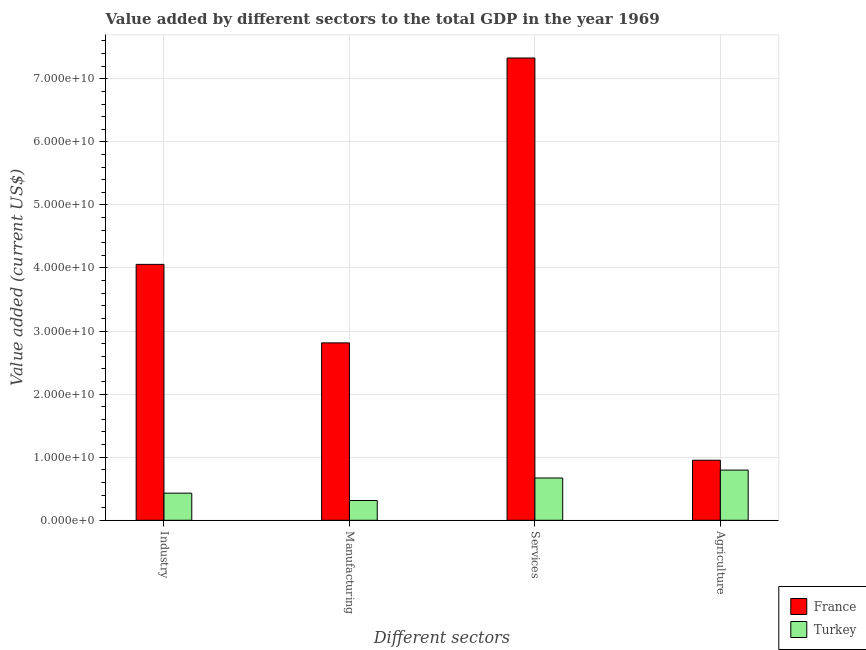How many different coloured bars are there?
Your response must be concise. 2. Are the number of bars per tick equal to the number of legend labels?
Provide a succinct answer. Yes. Are the number of bars on each tick of the X-axis equal?
Give a very brief answer. Yes. How many bars are there on the 3rd tick from the right?
Your response must be concise. 2. What is the label of the 3rd group of bars from the left?
Provide a short and direct response. Services. What is the value added by services sector in Turkey?
Your answer should be very brief. 6.70e+09. Across all countries, what is the maximum value added by services sector?
Ensure brevity in your answer.  7.33e+1. Across all countries, what is the minimum value added by manufacturing sector?
Give a very brief answer. 3.13e+09. In which country was the value added by services sector maximum?
Keep it short and to the point. France. What is the total value added by agricultural sector in the graph?
Offer a very short reply. 1.75e+1. What is the difference between the value added by agricultural sector in France and that in Turkey?
Offer a very short reply. 1.57e+09. What is the difference between the value added by manufacturing sector in Turkey and the value added by services sector in France?
Keep it short and to the point. -7.02e+1. What is the average value added by services sector per country?
Your answer should be compact. 4.00e+1. What is the difference between the value added by services sector and value added by manufacturing sector in France?
Your response must be concise. 4.52e+1. What is the ratio of the value added by services sector in France to that in Turkey?
Your answer should be compact. 10.94. Is the value added by agricultural sector in Turkey less than that in France?
Provide a succinct answer. Yes. Is the difference between the value added by industrial sector in Turkey and France greater than the difference between the value added by agricultural sector in Turkey and France?
Provide a succinct answer. No. What is the difference between the highest and the second highest value added by manufacturing sector?
Offer a very short reply. 2.50e+1. What is the difference between the highest and the lowest value added by services sector?
Ensure brevity in your answer.  6.66e+1. In how many countries, is the value added by manufacturing sector greater than the average value added by manufacturing sector taken over all countries?
Ensure brevity in your answer.  1. Is it the case that in every country, the sum of the value added by industrial sector and value added by manufacturing sector is greater than the value added by services sector?
Your response must be concise. No. Are the values on the major ticks of Y-axis written in scientific E-notation?
Offer a terse response. Yes. Does the graph contain any zero values?
Your response must be concise. No. How many legend labels are there?
Offer a very short reply. 2. What is the title of the graph?
Your answer should be very brief. Value added by different sectors to the total GDP in the year 1969. Does "Uzbekistan" appear as one of the legend labels in the graph?
Offer a very short reply. No. What is the label or title of the X-axis?
Provide a succinct answer. Different sectors. What is the label or title of the Y-axis?
Your response must be concise. Value added (current US$). What is the Value added (current US$) of France in Industry?
Make the answer very short. 4.06e+1. What is the Value added (current US$) in Turkey in Industry?
Provide a short and direct response. 4.30e+09. What is the Value added (current US$) in France in Manufacturing?
Your answer should be very brief. 2.81e+1. What is the Value added (current US$) of Turkey in Manufacturing?
Offer a very short reply. 3.13e+09. What is the Value added (current US$) in France in Services?
Ensure brevity in your answer.  7.33e+1. What is the Value added (current US$) of Turkey in Services?
Give a very brief answer. 6.70e+09. What is the Value added (current US$) in France in Agriculture?
Your response must be concise. 9.52e+09. What is the Value added (current US$) of Turkey in Agriculture?
Make the answer very short. 7.96e+09. Across all Different sectors, what is the maximum Value added (current US$) in France?
Give a very brief answer. 7.33e+1. Across all Different sectors, what is the maximum Value added (current US$) in Turkey?
Offer a terse response. 7.96e+09. Across all Different sectors, what is the minimum Value added (current US$) in France?
Keep it short and to the point. 9.52e+09. Across all Different sectors, what is the minimum Value added (current US$) of Turkey?
Provide a short and direct response. 3.13e+09. What is the total Value added (current US$) of France in the graph?
Keep it short and to the point. 1.52e+11. What is the total Value added (current US$) of Turkey in the graph?
Your response must be concise. 2.21e+1. What is the difference between the Value added (current US$) of France in Industry and that in Manufacturing?
Provide a short and direct response. 1.24e+1. What is the difference between the Value added (current US$) in Turkey in Industry and that in Manufacturing?
Make the answer very short. 1.17e+09. What is the difference between the Value added (current US$) in France in Industry and that in Services?
Keep it short and to the point. -3.27e+1. What is the difference between the Value added (current US$) of Turkey in Industry and that in Services?
Provide a short and direct response. -2.40e+09. What is the difference between the Value added (current US$) of France in Industry and that in Agriculture?
Offer a very short reply. 3.11e+1. What is the difference between the Value added (current US$) of Turkey in Industry and that in Agriculture?
Your answer should be very brief. -3.66e+09. What is the difference between the Value added (current US$) in France in Manufacturing and that in Services?
Offer a terse response. -4.52e+1. What is the difference between the Value added (current US$) in Turkey in Manufacturing and that in Services?
Provide a short and direct response. -3.57e+09. What is the difference between the Value added (current US$) in France in Manufacturing and that in Agriculture?
Give a very brief answer. 1.86e+1. What is the difference between the Value added (current US$) in Turkey in Manufacturing and that in Agriculture?
Your response must be concise. -4.82e+09. What is the difference between the Value added (current US$) of France in Services and that in Agriculture?
Keep it short and to the point. 6.38e+1. What is the difference between the Value added (current US$) in Turkey in Services and that in Agriculture?
Your answer should be very brief. -1.26e+09. What is the difference between the Value added (current US$) in France in Industry and the Value added (current US$) in Turkey in Manufacturing?
Offer a terse response. 3.74e+1. What is the difference between the Value added (current US$) in France in Industry and the Value added (current US$) in Turkey in Services?
Your answer should be very brief. 3.39e+1. What is the difference between the Value added (current US$) of France in Industry and the Value added (current US$) of Turkey in Agriculture?
Provide a succinct answer. 3.26e+1. What is the difference between the Value added (current US$) in France in Manufacturing and the Value added (current US$) in Turkey in Services?
Offer a very short reply. 2.14e+1. What is the difference between the Value added (current US$) of France in Manufacturing and the Value added (current US$) of Turkey in Agriculture?
Give a very brief answer. 2.02e+1. What is the difference between the Value added (current US$) in France in Services and the Value added (current US$) in Turkey in Agriculture?
Offer a very short reply. 6.53e+1. What is the average Value added (current US$) in France per Different sectors?
Give a very brief answer. 3.79e+1. What is the average Value added (current US$) in Turkey per Different sectors?
Give a very brief answer. 5.52e+09. What is the difference between the Value added (current US$) in France and Value added (current US$) in Turkey in Industry?
Give a very brief answer. 3.63e+1. What is the difference between the Value added (current US$) of France and Value added (current US$) of Turkey in Manufacturing?
Keep it short and to the point. 2.50e+1. What is the difference between the Value added (current US$) of France and Value added (current US$) of Turkey in Services?
Offer a very short reply. 6.66e+1. What is the difference between the Value added (current US$) in France and Value added (current US$) in Turkey in Agriculture?
Your response must be concise. 1.57e+09. What is the ratio of the Value added (current US$) of France in Industry to that in Manufacturing?
Keep it short and to the point. 1.44. What is the ratio of the Value added (current US$) of Turkey in Industry to that in Manufacturing?
Keep it short and to the point. 1.37. What is the ratio of the Value added (current US$) of France in Industry to that in Services?
Offer a terse response. 0.55. What is the ratio of the Value added (current US$) of Turkey in Industry to that in Services?
Make the answer very short. 0.64. What is the ratio of the Value added (current US$) of France in Industry to that in Agriculture?
Your answer should be compact. 4.26. What is the ratio of the Value added (current US$) in Turkey in Industry to that in Agriculture?
Keep it short and to the point. 0.54. What is the ratio of the Value added (current US$) of France in Manufacturing to that in Services?
Your answer should be compact. 0.38. What is the ratio of the Value added (current US$) of Turkey in Manufacturing to that in Services?
Offer a terse response. 0.47. What is the ratio of the Value added (current US$) of France in Manufacturing to that in Agriculture?
Provide a short and direct response. 2.95. What is the ratio of the Value added (current US$) in Turkey in Manufacturing to that in Agriculture?
Offer a terse response. 0.39. What is the ratio of the Value added (current US$) in France in Services to that in Agriculture?
Your answer should be compact. 7.7. What is the ratio of the Value added (current US$) in Turkey in Services to that in Agriculture?
Your response must be concise. 0.84. What is the difference between the highest and the second highest Value added (current US$) in France?
Offer a terse response. 3.27e+1. What is the difference between the highest and the second highest Value added (current US$) in Turkey?
Your response must be concise. 1.26e+09. What is the difference between the highest and the lowest Value added (current US$) of France?
Your response must be concise. 6.38e+1. What is the difference between the highest and the lowest Value added (current US$) of Turkey?
Give a very brief answer. 4.82e+09. 